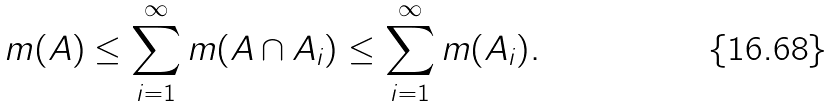<formula> <loc_0><loc_0><loc_500><loc_500>m ( A ) \leq \sum _ { i = 1 } ^ { \infty } m ( A \cap A _ { i } ) \leq \sum _ { i = 1 } ^ { \infty } m ( A _ { i } ) .</formula> 